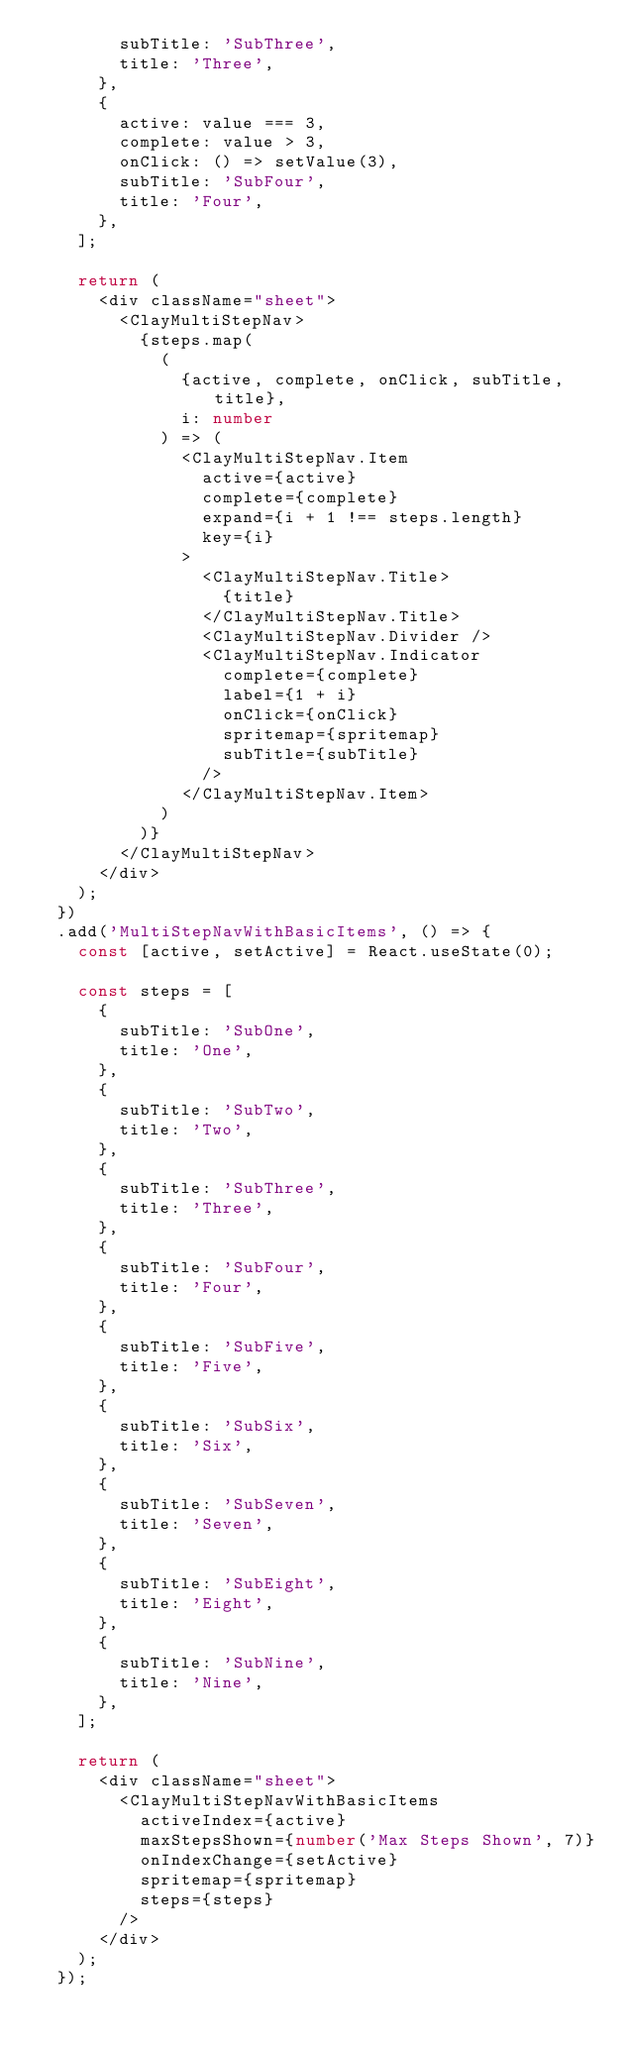Convert code to text. <code><loc_0><loc_0><loc_500><loc_500><_TypeScript_>				subTitle: 'SubThree',
				title: 'Three',
			},
			{
				active: value === 3,
				complete: value > 3,
				onClick: () => setValue(3),
				subTitle: 'SubFour',
				title: 'Four',
			},
		];

		return (
			<div className="sheet">
				<ClayMultiStepNav>
					{steps.map(
						(
							{active, complete, onClick, subTitle, title},
							i: number
						) => (
							<ClayMultiStepNav.Item
								active={active}
								complete={complete}
								expand={i + 1 !== steps.length}
								key={i}
							>
								<ClayMultiStepNav.Title>
									{title}
								</ClayMultiStepNav.Title>
								<ClayMultiStepNav.Divider />
								<ClayMultiStepNav.Indicator
									complete={complete}
									label={1 + i}
									onClick={onClick}
									spritemap={spritemap}
									subTitle={subTitle}
								/>
							</ClayMultiStepNav.Item>
						)
					)}
				</ClayMultiStepNav>
			</div>
		);
	})
	.add('MultiStepNavWithBasicItems', () => {
		const [active, setActive] = React.useState(0);

		const steps = [
			{
				subTitle: 'SubOne',
				title: 'One',
			},
			{
				subTitle: 'SubTwo',
				title: 'Two',
			},
			{
				subTitle: 'SubThree',
				title: 'Three',
			},
			{
				subTitle: 'SubFour',
				title: 'Four',
			},
			{
				subTitle: 'SubFive',
				title: 'Five',
			},
			{
				subTitle: 'SubSix',
				title: 'Six',
			},
			{
				subTitle: 'SubSeven',
				title: 'Seven',
			},
			{
				subTitle: 'SubEight',
				title: 'Eight',
			},
			{
				subTitle: 'SubNine',
				title: 'Nine',
			},
		];

		return (
			<div className="sheet">
				<ClayMultiStepNavWithBasicItems
					activeIndex={active}
					maxStepsShown={number('Max Steps Shown', 7)}
					onIndexChange={setActive}
					spritemap={spritemap}
					steps={steps}
				/>
			</div>
		);
	});
</code> 